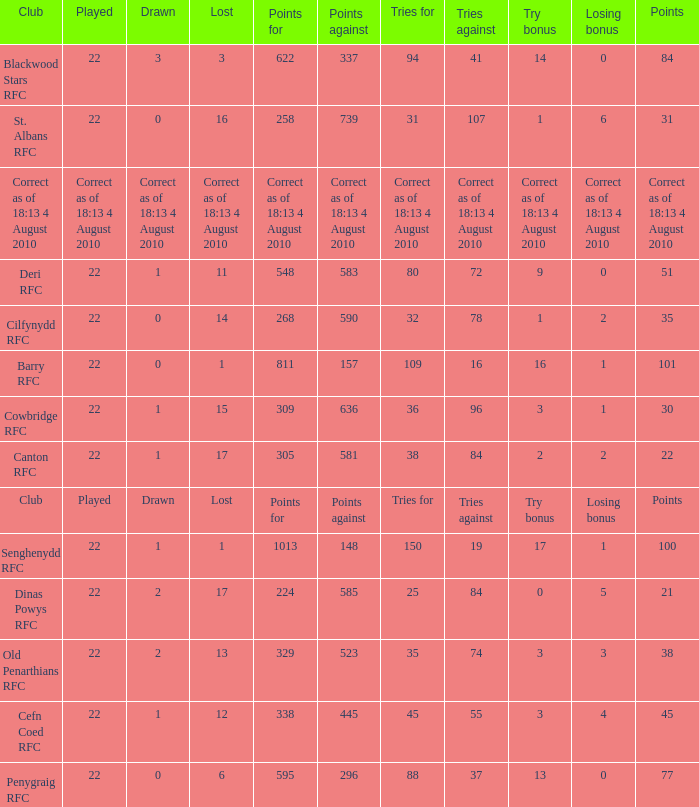What is the name of the club when the played number is 22, and the try bonus was 0? Dinas Powys RFC. 